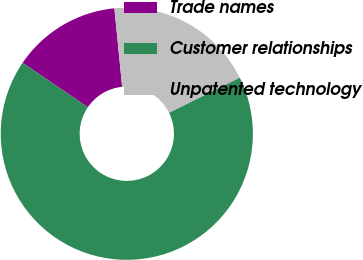<chart> <loc_0><loc_0><loc_500><loc_500><pie_chart><fcel>Trade names<fcel>Customer relationships<fcel>Unpatented technology<nl><fcel>13.92%<fcel>66.86%<fcel>19.22%<nl></chart> 